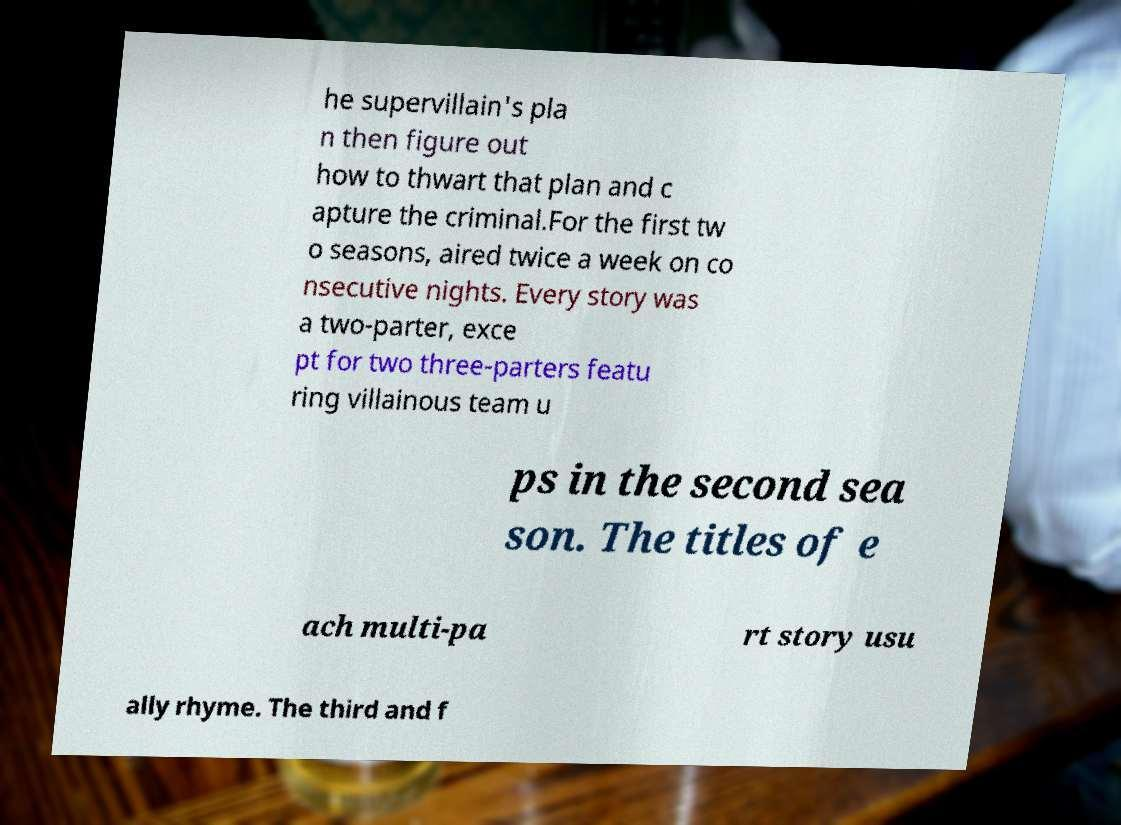I need the written content from this picture converted into text. Can you do that? he supervillain's pla n then figure out how to thwart that plan and c apture the criminal.For the first tw o seasons, aired twice a week on co nsecutive nights. Every story was a two-parter, exce pt for two three-parters featu ring villainous team u ps in the second sea son. The titles of e ach multi-pa rt story usu ally rhyme. The third and f 